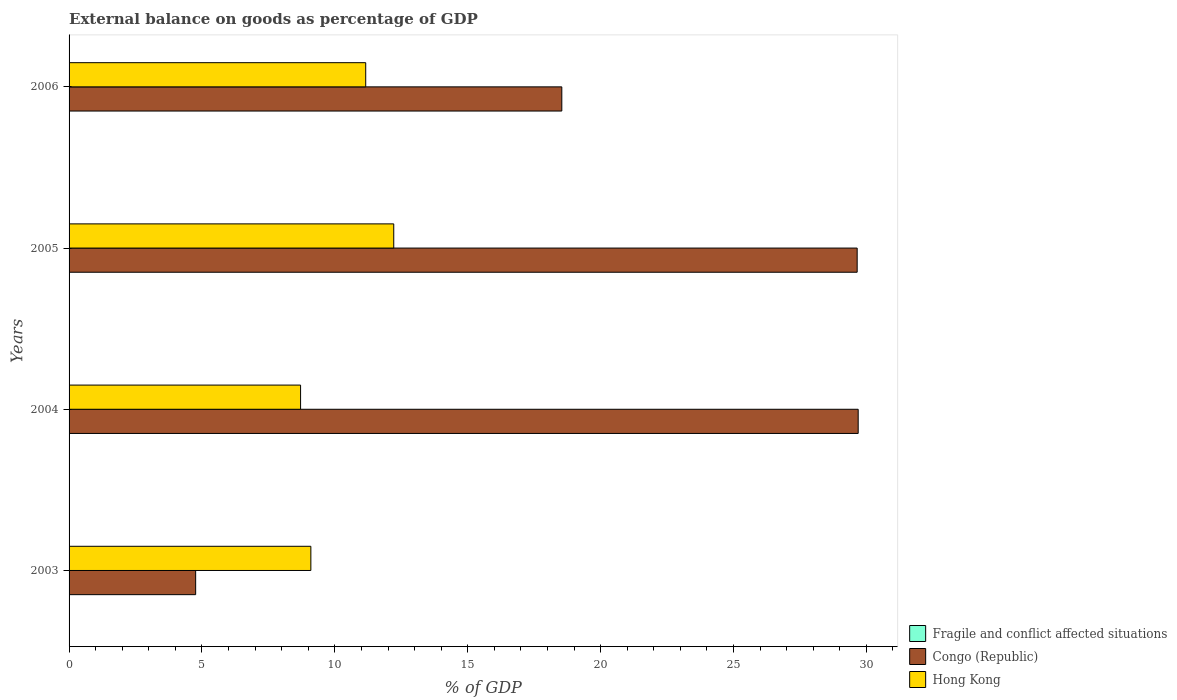How many different coloured bars are there?
Offer a very short reply. 2. How many groups of bars are there?
Your answer should be compact. 4. Are the number of bars per tick equal to the number of legend labels?
Ensure brevity in your answer.  No. What is the label of the 3rd group of bars from the top?
Make the answer very short. 2004. In how many cases, is the number of bars for a given year not equal to the number of legend labels?
Offer a terse response. 4. What is the external balance on goods as percentage of GDP in Hong Kong in 2003?
Offer a very short reply. 9.1. Across all years, what is the maximum external balance on goods as percentage of GDP in Hong Kong?
Your response must be concise. 12.22. Across all years, what is the minimum external balance on goods as percentage of GDP in Fragile and conflict affected situations?
Offer a very short reply. 0. In which year was the external balance on goods as percentage of GDP in Congo (Republic) maximum?
Ensure brevity in your answer.  2004. What is the total external balance on goods as percentage of GDP in Hong Kong in the graph?
Your answer should be compact. 41.19. What is the difference between the external balance on goods as percentage of GDP in Hong Kong in 2005 and that in 2006?
Your answer should be very brief. 1.05. What is the difference between the external balance on goods as percentage of GDP in Fragile and conflict affected situations in 2004 and the external balance on goods as percentage of GDP in Congo (Republic) in 2006?
Provide a succinct answer. -18.54. What is the average external balance on goods as percentage of GDP in Hong Kong per year?
Provide a short and direct response. 10.3. In the year 2004, what is the difference between the external balance on goods as percentage of GDP in Congo (Republic) and external balance on goods as percentage of GDP in Hong Kong?
Make the answer very short. 20.98. What is the ratio of the external balance on goods as percentage of GDP in Hong Kong in 2004 to that in 2005?
Your response must be concise. 0.71. Is the external balance on goods as percentage of GDP in Hong Kong in 2004 less than that in 2006?
Your answer should be very brief. Yes. Is the difference between the external balance on goods as percentage of GDP in Congo (Republic) in 2003 and 2004 greater than the difference between the external balance on goods as percentage of GDP in Hong Kong in 2003 and 2004?
Make the answer very short. No. What is the difference between the highest and the second highest external balance on goods as percentage of GDP in Congo (Republic)?
Your response must be concise. 0.04. What is the difference between the highest and the lowest external balance on goods as percentage of GDP in Hong Kong?
Your response must be concise. 3.51. In how many years, is the external balance on goods as percentage of GDP in Congo (Republic) greater than the average external balance on goods as percentage of GDP in Congo (Republic) taken over all years?
Keep it short and to the point. 2. Is it the case that in every year, the sum of the external balance on goods as percentage of GDP in Congo (Republic) and external balance on goods as percentage of GDP in Fragile and conflict affected situations is greater than the external balance on goods as percentage of GDP in Hong Kong?
Keep it short and to the point. No. How many bars are there?
Make the answer very short. 8. Are all the bars in the graph horizontal?
Your response must be concise. Yes. How many years are there in the graph?
Ensure brevity in your answer.  4. What is the difference between two consecutive major ticks on the X-axis?
Provide a succinct answer. 5. Are the values on the major ticks of X-axis written in scientific E-notation?
Offer a terse response. No. Does the graph contain any zero values?
Give a very brief answer. Yes. Does the graph contain grids?
Offer a very short reply. No. What is the title of the graph?
Your answer should be very brief. External balance on goods as percentage of GDP. What is the label or title of the X-axis?
Keep it short and to the point. % of GDP. What is the % of GDP of Fragile and conflict affected situations in 2003?
Offer a very short reply. 0. What is the % of GDP of Congo (Republic) in 2003?
Give a very brief answer. 4.76. What is the % of GDP in Hong Kong in 2003?
Your response must be concise. 9.1. What is the % of GDP in Congo (Republic) in 2004?
Your response must be concise. 29.69. What is the % of GDP of Hong Kong in 2004?
Offer a terse response. 8.71. What is the % of GDP of Fragile and conflict affected situations in 2005?
Offer a terse response. 0. What is the % of GDP of Congo (Republic) in 2005?
Provide a short and direct response. 29.65. What is the % of GDP in Hong Kong in 2005?
Provide a short and direct response. 12.22. What is the % of GDP of Fragile and conflict affected situations in 2006?
Make the answer very short. 0. What is the % of GDP in Congo (Republic) in 2006?
Keep it short and to the point. 18.54. What is the % of GDP in Hong Kong in 2006?
Offer a very short reply. 11.16. Across all years, what is the maximum % of GDP in Congo (Republic)?
Make the answer very short. 29.69. Across all years, what is the maximum % of GDP in Hong Kong?
Give a very brief answer. 12.22. Across all years, what is the minimum % of GDP in Congo (Republic)?
Provide a short and direct response. 4.76. Across all years, what is the minimum % of GDP of Hong Kong?
Provide a succinct answer. 8.71. What is the total % of GDP of Fragile and conflict affected situations in the graph?
Your response must be concise. 0. What is the total % of GDP in Congo (Republic) in the graph?
Provide a short and direct response. 82.65. What is the total % of GDP of Hong Kong in the graph?
Offer a very short reply. 41.19. What is the difference between the % of GDP of Congo (Republic) in 2003 and that in 2004?
Offer a very short reply. -24.93. What is the difference between the % of GDP of Hong Kong in 2003 and that in 2004?
Ensure brevity in your answer.  0.39. What is the difference between the % of GDP of Congo (Republic) in 2003 and that in 2005?
Make the answer very short. -24.89. What is the difference between the % of GDP in Hong Kong in 2003 and that in 2005?
Offer a very short reply. -3.12. What is the difference between the % of GDP of Congo (Republic) in 2003 and that in 2006?
Give a very brief answer. -13.78. What is the difference between the % of GDP of Hong Kong in 2003 and that in 2006?
Provide a succinct answer. -2.06. What is the difference between the % of GDP of Congo (Republic) in 2004 and that in 2005?
Give a very brief answer. 0.04. What is the difference between the % of GDP in Hong Kong in 2004 and that in 2005?
Your answer should be very brief. -3.51. What is the difference between the % of GDP of Congo (Republic) in 2004 and that in 2006?
Provide a short and direct response. 11.15. What is the difference between the % of GDP in Hong Kong in 2004 and that in 2006?
Ensure brevity in your answer.  -2.45. What is the difference between the % of GDP in Congo (Republic) in 2005 and that in 2006?
Your answer should be very brief. 11.11. What is the difference between the % of GDP of Hong Kong in 2005 and that in 2006?
Your response must be concise. 1.05. What is the difference between the % of GDP of Congo (Republic) in 2003 and the % of GDP of Hong Kong in 2004?
Give a very brief answer. -3.95. What is the difference between the % of GDP in Congo (Republic) in 2003 and the % of GDP in Hong Kong in 2005?
Your answer should be compact. -7.45. What is the difference between the % of GDP of Congo (Republic) in 2003 and the % of GDP of Hong Kong in 2006?
Your answer should be compact. -6.4. What is the difference between the % of GDP of Congo (Republic) in 2004 and the % of GDP of Hong Kong in 2005?
Provide a short and direct response. 17.47. What is the difference between the % of GDP of Congo (Republic) in 2004 and the % of GDP of Hong Kong in 2006?
Your answer should be very brief. 18.53. What is the difference between the % of GDP in Congo (Republic) in 2005 and the % of GDP in Hong Kong in 2006?
Provide a succinct answer. 18.49. What is the average % of GDP in Congo (Republic) per year?
Offer a very short reply. 20.66. What is the average % of GDP of Hong Kong per year?
Offer a terse response. 10.3. In the year 2003, what is the difference between the % of GDP of Congo (Republic) and % of GDP of Hong Kong?
Your response must be concise. -4.33. In the year 2004, what is the difference between the % of GDP of Congo (Republic) and % of GDP of Hong Kong?
Offer a very short reply. 20.98. In the year 2005, what is the difference between the % of GDP in Congo (Republic) and % of GDP in Hong Kong?
Your answer should be compact. 17.44. In the year 2006, what is the difference between the % of GDP in Congo (Republic) and % of GDP in Hong Kong?
Your answer should be very brief. 7.38. What is the ratio of the % of GDP in Congo (Republic) in 2003 to that in 2004?
Provide a succinct answer. 0.16. What is the ratio of the % of GDP of Hong Kong in 2003 to that in 2004?
Offer a terse response. 1.04. What is the ratio of the % of GDP of Congo (Republic) in 2003 to that in 2005?
Offer a very short reply. 0.16. What is the ratio of the % of GDP of Hong Kong in 2003 to that in 2005?
Offer a terse response. 0.74. What is the ratio of the % of GDP of Congo (Republic) in 2003 to that in 2006?
Your answer should be very brief. 0.26. What is the ratio of the % of GDP of Hong Kong in 2003 to that in 2006?
Ensure brevity in your answer.  0.81. What is the ratio of the % of GDP of Congo (Republic) in 2004 to that in 2005?
Your response must be concise. 1. What is the ratio of the % of GDP in Hong Kong in 2004 to that in 2005?
Give a very brief answer. 0.71. What is the ratio of the % of GDP of Congo (Republic) in 2004 to that in 2006?
Offer a very short reply. 1.6. What is the ratio of the % of GDP in Hong Kong in 2004 to that in 2006?
Provide a short and direct response. 0.78. What is the ratio of the % of GDP of Congo (Republic) in 2005 to that in 2006?
Your answer should be compact. 1.6. What is the ratio of the % of GDP of Hong Kong in 2005 to that in 2006?
Your answer should be very brief. 1.09. What is the difference between the highest and the second highest % of GDP in Congo (Republic)?
Offer a very short reply. 0.04. What is the difference between the highest and the second highest % of GDP in Hong Kong?
Keep it short and to the point. 1.05. What is the difference between the highest and the lowest % of GDP of Congo (Republic)?
Ensure brevity in your answer.  24.93. What is the difference between the highest and the lowest % of GDP in Hong Kong?
Ensure brevity in your answer.  3.51. 